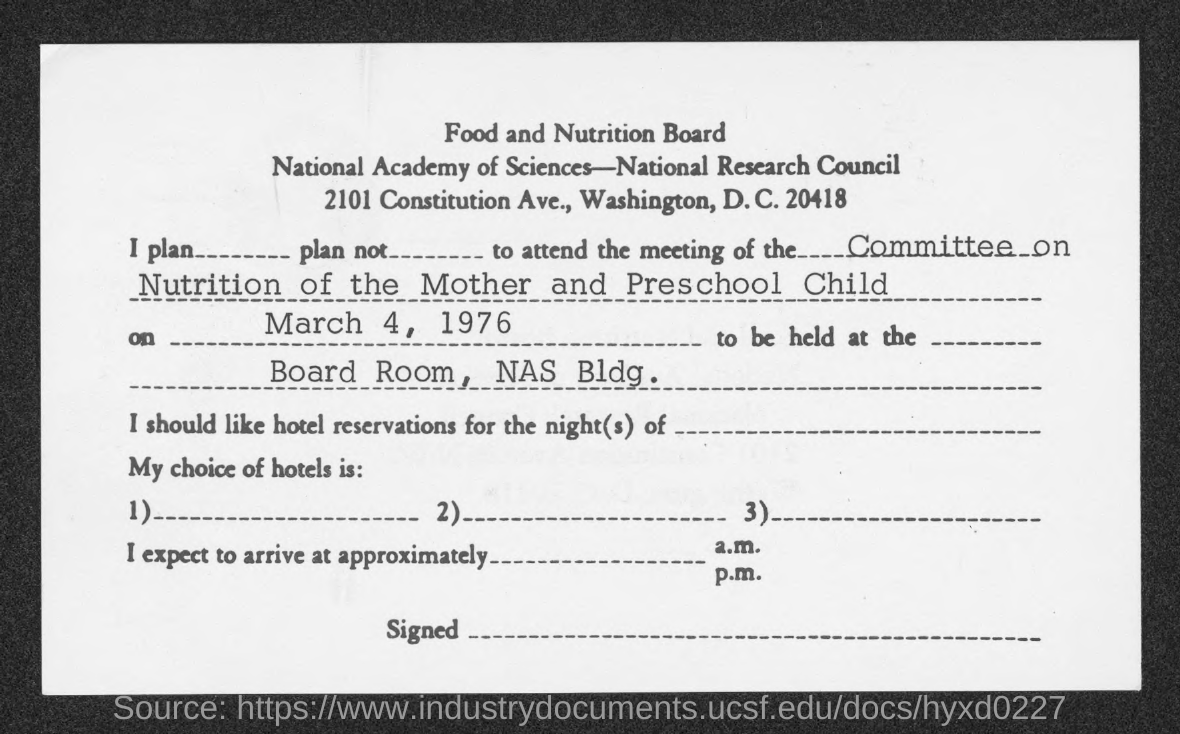Specify some key components in this picture. The Food and Nutrition Board is the name of the board mentioned in the given form. The date of the meeting is March 4, 1976. 